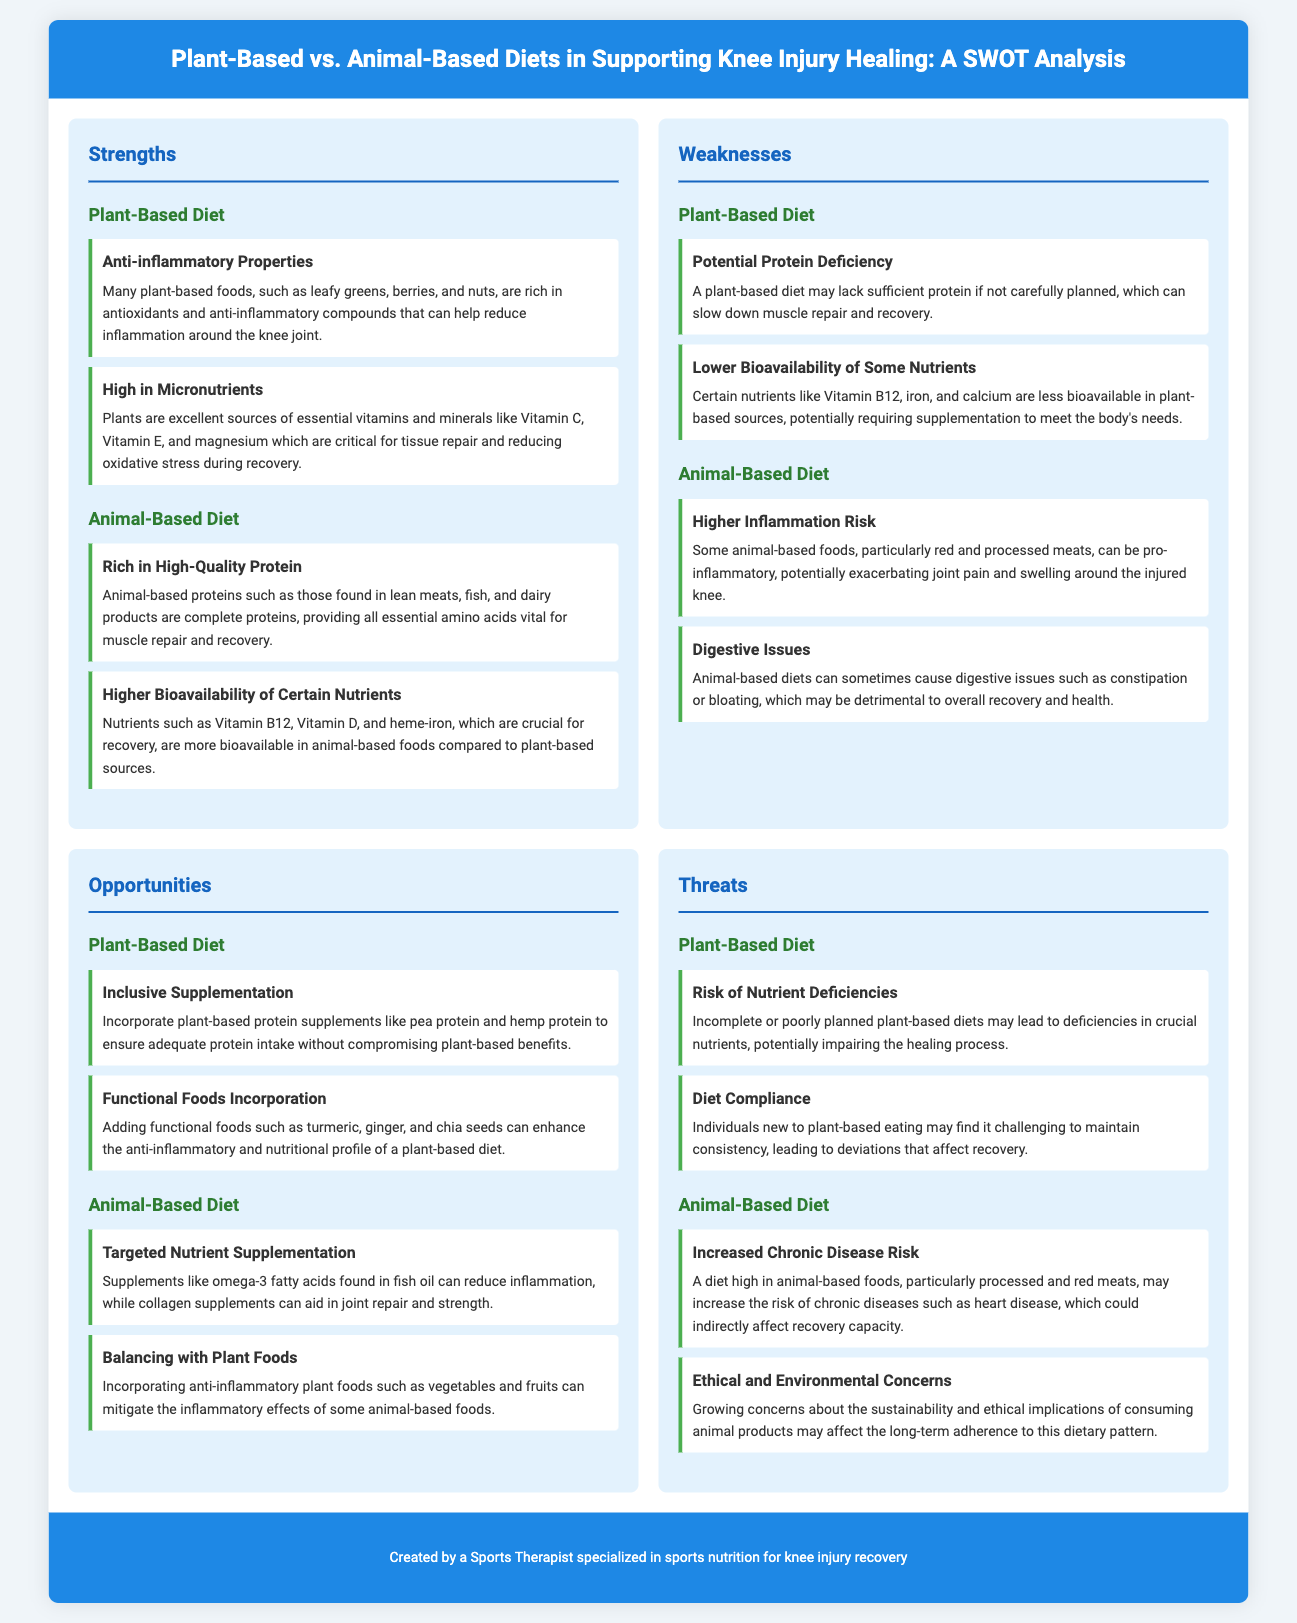what are two strengths of a plant-based diet? The strengths listed for a plant-based diet are "Anti-inflammatory Properties" and "High in Micronutrients."
Answer: Anti-inflammatory Properties, High in Micronutrients how many weaknesses are listed for the animal-based diet? The document lists two weaknesses for the animal-based diet: "Higher Inflammation Risk" and "Digestive Issues."
Answer: 2 name one opportunity for a plant-based diet. The opportunities for a plant-based diet include "Inclusive Supplementation" and "Functional Foods Incorporation."
Answer: Inclusive Supplementation what is a threat associated with the animal-based diet? The threats noted for the animal-based diet include "Increased Chronic Disease Risk" and "Ethical and Environmental Concerns."
Answer: Increased Chronic Disease Risk which essential nutrient is mentioned as being more bioavailable in animal-based foods? The document states that nutrients like Vitamin B12, Vitamin D, and heme-iron have higher bioavailability in animal foods.
Answer: Vitamin B12 what type of document is this analysis? The document is structured as a SWOT analysis, assessing the strengths, weaknesses, opportunities, and threats of diets.
Answer: SWOT analysis list one weakness of a plant-based diet. The document identifies "Potential Protein Deficiency" as a weakness of a plant-based diet.
Answer: Potential Protein Deficiency what is one potential risk mentioned for a plant-based diet? One potential risk for a plant-based diet is "Risk of Nutrient Deficiencies."
Answer: Risk of Nutrient Deficiencies which supplement is suggested for animal-based diets to aid in joint repair? The document suggests collagen supplements for aiding in joint repair in animal-based diets.
Answer: collagen supplements 